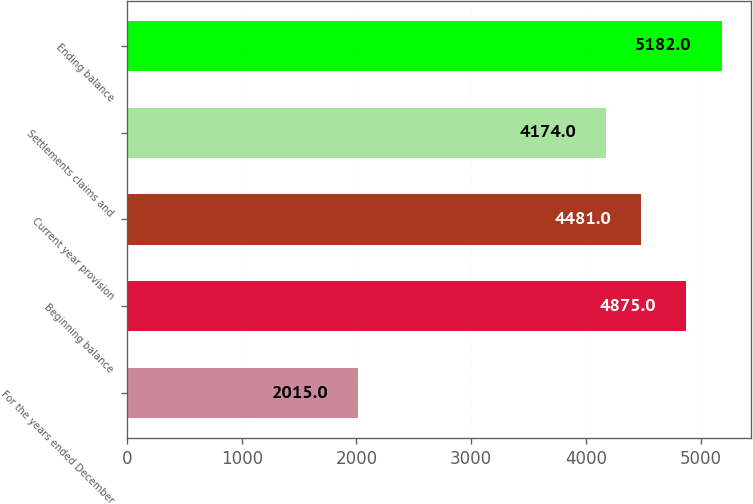Convert chart to OTSL. <chart><loc_0><loc_0><loc_500><loc_500><bar_chart><fcel>For the years ended December<fcel>Beginning balance<fcel>Current year provision<fcel>Settlements claims and<fcel>Ending balance<nl><fcel>2015<fcel>4875<fcel>4481<fcel>4174<fcel>5182<nl></chart> 